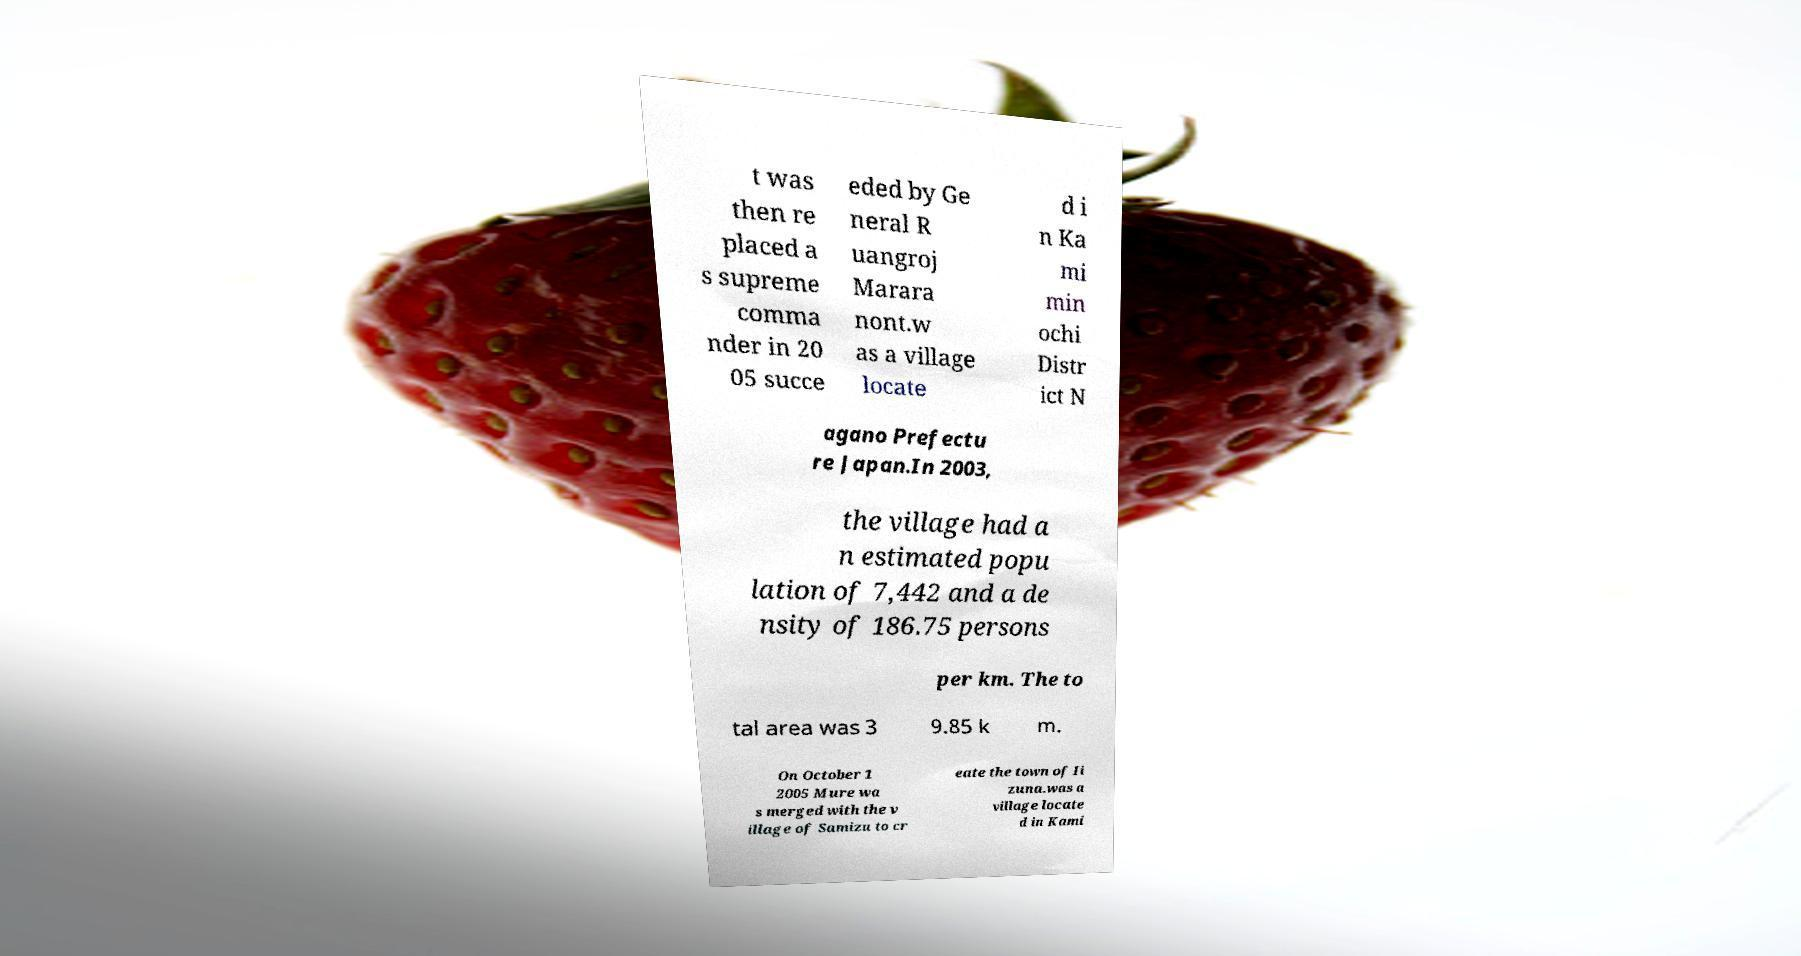Could you assist in decoding the text presented in this image and type it out clearly? t was then re placed a s supreme comma nder in 20 05 succe eded by Ge neral R uangroj Marara nont.w as a village locate d i n Ka mi min ochi Distr ict N agano Prefectu re Japan.In 2003, the village had a n estimated popu lation of 7,442 and a de nsity of 186.75 persons per km. The to tal area was 3 9.85 k m. On October 1 2005 Mure wa s merged with the v illage of Samizu to cr eate the town of Ii zuna.was a village locate d in Kami 